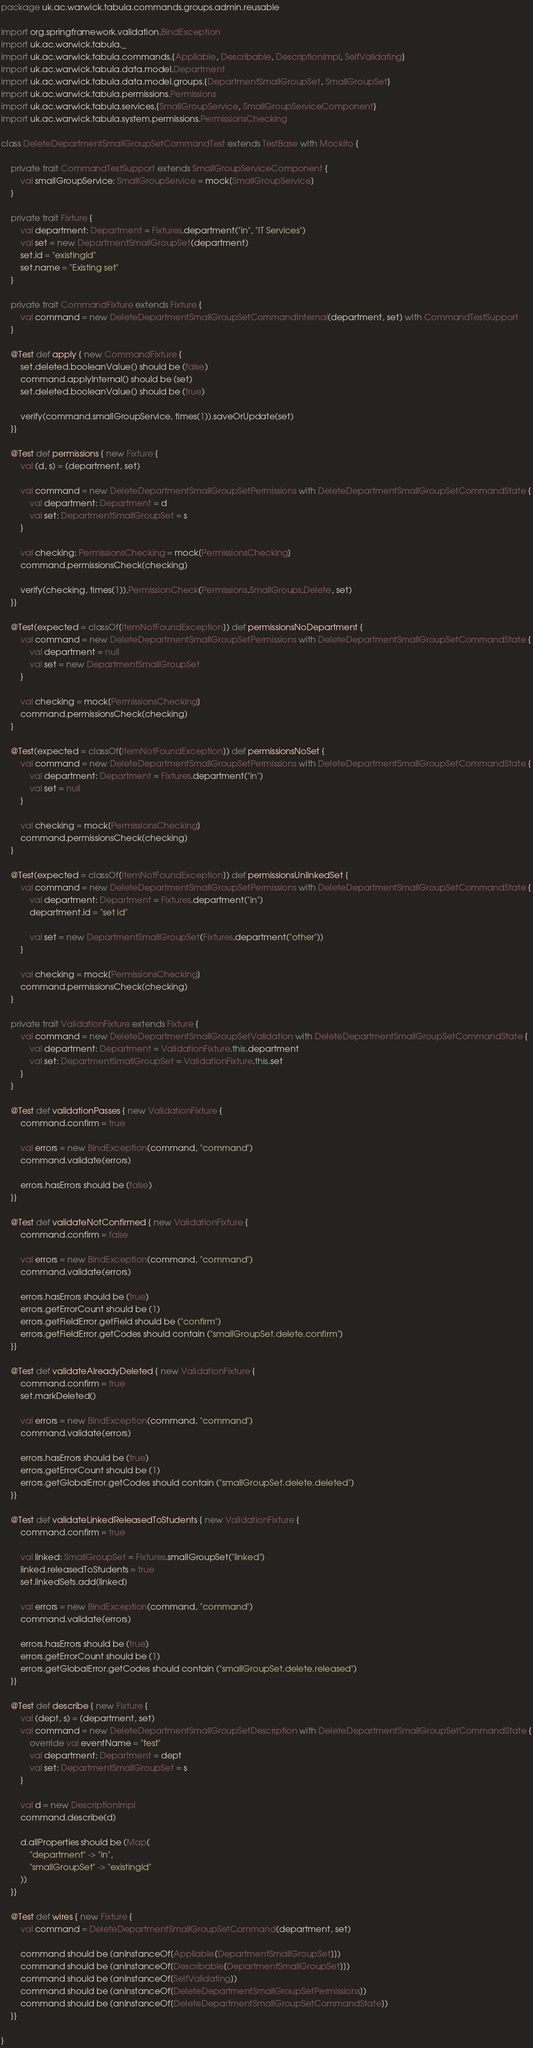<code> <loc_0><loc_0><loc_500><loc_500><_Scala_>package uk.ac.warwick.tabula.commands.groups.admin.reusable

import org.springframework.validation.BindException
import uk.ac.warwick.tabula._
import uk.ac.warwick.tabula.commands.{Appliable, Describable, DescriptionImpl, SelfValidating}
import uk.ac.warwick.tabula.data.model.Department
import uk.ac.warwick.tabula.data.model.groups.{DepartmentSmallGroupSet, SmallGroupSet}
import uk.ac.warwick.tabula.permissions.Permissions
import uk.ac.warwick.tabula.services.{SmallGroupService, SmallGroupServiceComponent}
import uk.ac.warwick.tabula.system.permissions.PermissionsChecking

class DeleteDepartmentSmallGroupSetCommandTest extends TestBase with Mockito {

	private trait CommandTestSupport extends SmallGroupServiceComponent {
		val smallGroupService: SmallGroupService = mock[SmallGroupService]
	}

	private trait Fixture {
		val department: Department = Fixtures.department("in", "IT Services")
		val set = new DepartmentSmallGroupSet(department)
		set.id = "existingId"
		set.name = "Existing set"
	}

	private trait CommandFixture extends Fixture {
		val command = new DeleteDepartmentSmallGroupSetCommandInternal(department, set) with CommandTestSupport
	}

	@Test def apply { new CommandFixture {
		set.deleted.booleanValue() should be (false)
		command.applyInternal() should be (set)
		set.deleted.booleanValue() should be (true)

		verify(command.smallGroupService, times(1)).saveOrUpdate(set)
	}}

	@Test def permissions { new Fixture {
		val (d, s) = (department, set)

		val command = new DeleteDepartmentSmallGroupSetPermissions with DeleteDepartmentSmallGroupSetCommandState {
			val department: Department = d
			val set: DepartmentSmallGroupSet = s
		}

		val checking: PermissionsChecking = mock[PermissionsChecking]
		command.permissionsCheck(checking)

		verify(checking, times(1)).PermissionCheck(Permissions.SmallGroups.Delete, set)
	}}

	@Test(expected = classOf[ItemNotFoundException]) def permissionsNoDepartment {
		val command = new DeleteDepartmentSmallGroupSetPermissions with DeleteDepartmentSmallGroupSetCommandState {
			val department = null
			val set = new DepartmentSmallGroupSet
		}

		val checking = mock[PermissionsChecking]
		command.permissionsCheck(checking)
	}

	@Test(expected = classOf[ItemNotFoundException]) def permissionsNoSet {
		val command = new DeleteDepartmentSmallGroupSetPermissions with DeleteDepartmentSmallGroupSetCommandState {
			val department: Department = Fixtures.department("in")
			val set = null
		}

		val checking = mock[PermissionsChecking]
		command.permissionsCheck(checking)
	}

	@Test(expected = classOf[ItemNotFoundException]) def permissionsUnlinkedSet {
		val command = new DeleteDepartmentSmallGroupSetPermissions with DeleteDepartmentSmallGroupSetCommandState {
			val department: Department = Fixtures.department("in")
			department.id = "set id"

			val set = new DepartmentSmallGroupSet(Fixtures.department("other"))
		}

		val checking = mock[PermissionsChecking]
		command.permissionsCheck(checking)
	}

	private trait ValidationFixture extends Fixture {
		val command = new DeleteDepartmentSmallGroupSetValidation with DeleteDepartmentSmallGroupSetCommandState {
			val department: Department = ValidationFixture.this.department
			val set: DepartmentSmallGroupSet = ValidationFixture.this.set
		}
	}

	@Test def validationPasses { new ValidationFixture {
		command.confirm = true

		val errors = new BindException(command, "command")
		command.validate(errors)

		errors.hasErrors should be (false)
	}}

	@Test def validateNotConfirmed { new ValidationFixture {
		command.confirm = false

		val errors = new BindException(command, "command")
		command.validate(errors)

		errors.hasErrors should be (true)
		errors.getErrorCount should be (1)
		errors.getFieldError.getField should be ("confirm")
		errors.getFieldError.getCodes should contain ("smallGroupSet.delete.confirm")
	}}

	@Test def validateAlreadyDeleted { new ValidationFixture {
		command.confirm = true
		set.markDeleted()

		val errors = new BindException(command, "command")
		command.validate(errors)

		errors.hasErrors should be (true)
		errors.getErrorCount should be (1)
		errors.getGlobalError.getCodes should contain ("smallGroupSet.delete.deleted")
	}}

	@Test def validateLinkedReleasedToStudents { new ValidationFixture {
		command.confirm = true

		val linked: SmallGroupSet = Fixtures.smallGroupSet("linked")
		linked.releasedToStudents = true
		set.linkedSets.add(linked)

		val errors = new BindException(command, "command")
		command.validate(errors)

		errors.hasErrors should be (true)
		errors.getErrorCount should be (1)
		errors.getGlobalError.getCodes should contain ("smallGroupSet.delete.released")
	}}

	@Test def describe { new Fixture {
		val (dept, s) = (department, set)
		val command = new DeleteDepartmentSmallGroupSetDescription with DeleteDepartmentSmallGroupSetCommandState {
			override val eventName = "test"
			val department: Department = dept
			val set: DepartmentSmallGroupSet = s
		}

		val d = new DescriptionImpl
		command.describe(d)

		d.allProperties should be (Map(
			"department" -> "in",
			"smallGroupSet" -> "existingId"
		))
	}}

	@Test def wires { new Fixture {
		val command = DeleteDepartmentSmallGroupSetCommand(department, set)

		command should be (anInstanceOf[Appliable[DepartmentSmallGroupSet]])
		command should be (anInstanceOf[Describable[DepartmentSmallGroupSet]])
		command should be (anInstanceOf[SelfValidating])
		command should be (anInstanceOf[DeleteDepartmentSmallGroupSetPermissions])
		command should be (anInstanceOf[DeleteDepartmentSmallGroupSetCommandState])
	}}

}
</code> 